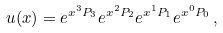Convert formula to latex. <formula><loc_0><loc_0><loc_500><loc_500>u ( x ) = e ^ { x ^ { 3 } P _ { 3 } } e ^ { x ^ { 2 } P _ { 2 } } e ^ { x ^ { 1 } P _ { 1 } } e ^ { x ^ { 0 } P _ { 0 } } \, ,</formula> 